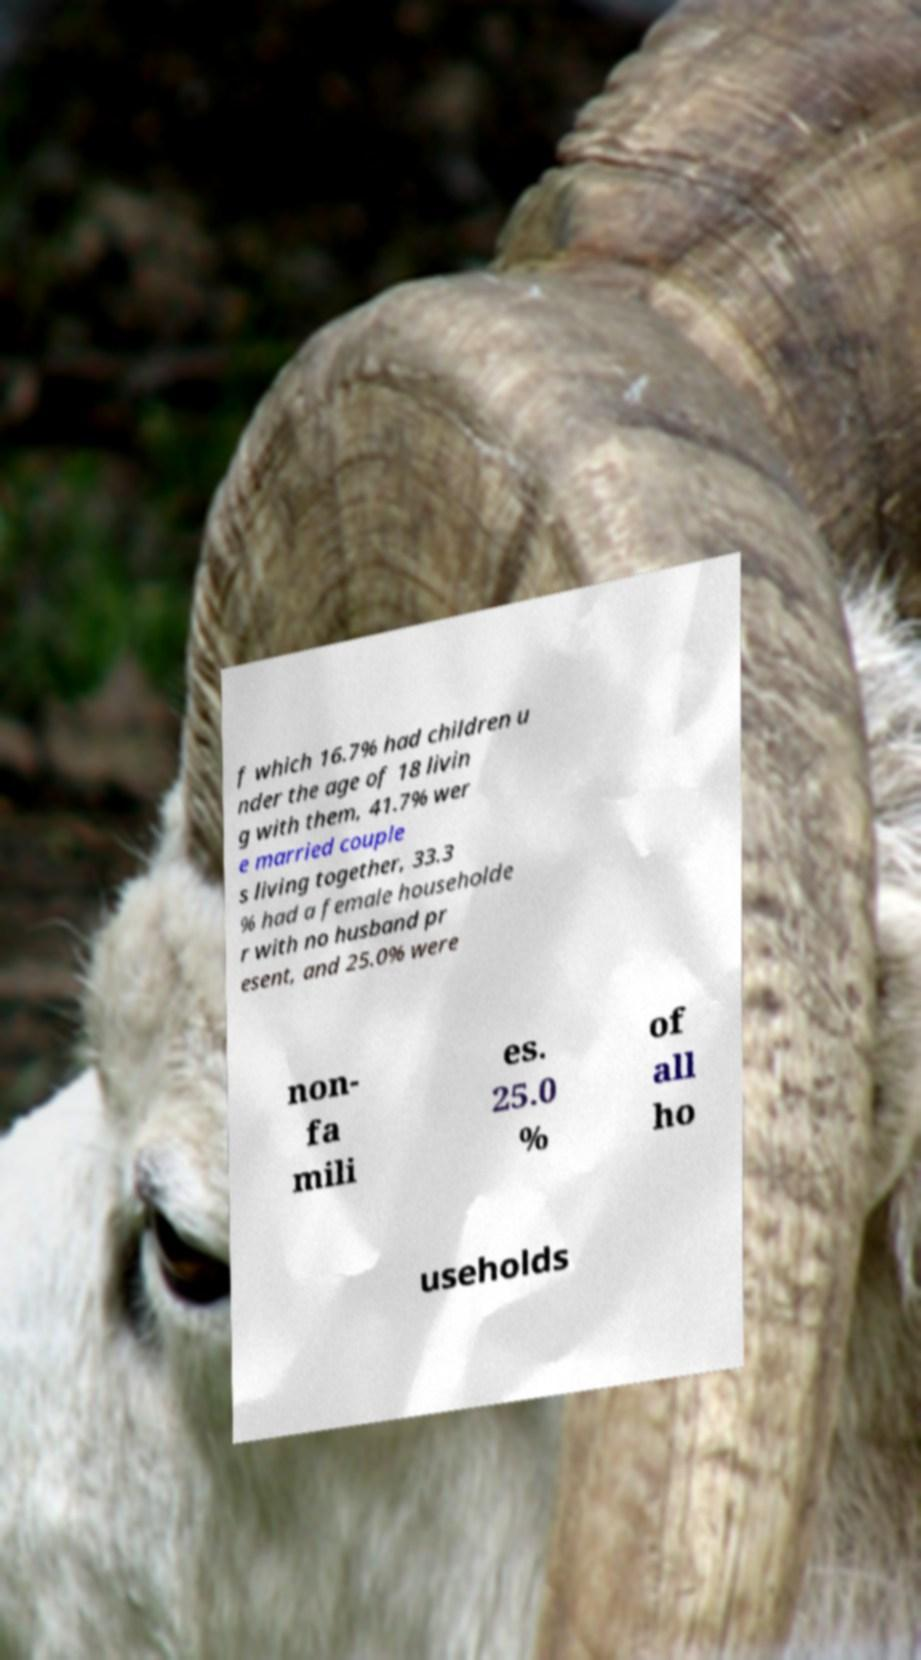For documentation purposes, I need the text within this image transcribed. Could you provide that? f which 16.7% had children u nder the age of 18 livin g with them, 41.7% wer e married couple s living together, 33.3 % had a female householde r with no husband pr esent, and 25.0% were non- fa mili es. 25.0 % of all ho useholds 